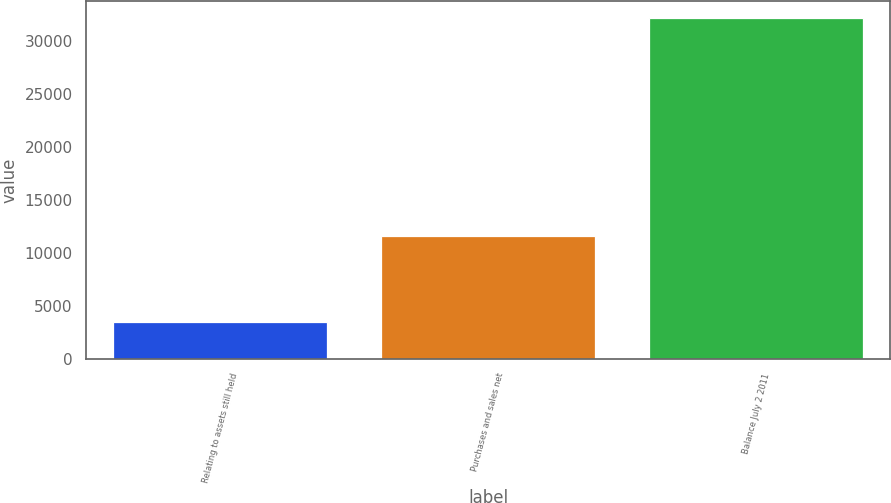Convert chart to OTSL. <chart><loc_0><loc_0><loc_500><loc_500><bar_chart><fcel>Relating to assets still held<fcel>Purchases and sales net<fcel>Balance July 2 2011<nl><fcel>3443<fcel>11587<fcel>32095<nl></chart> 